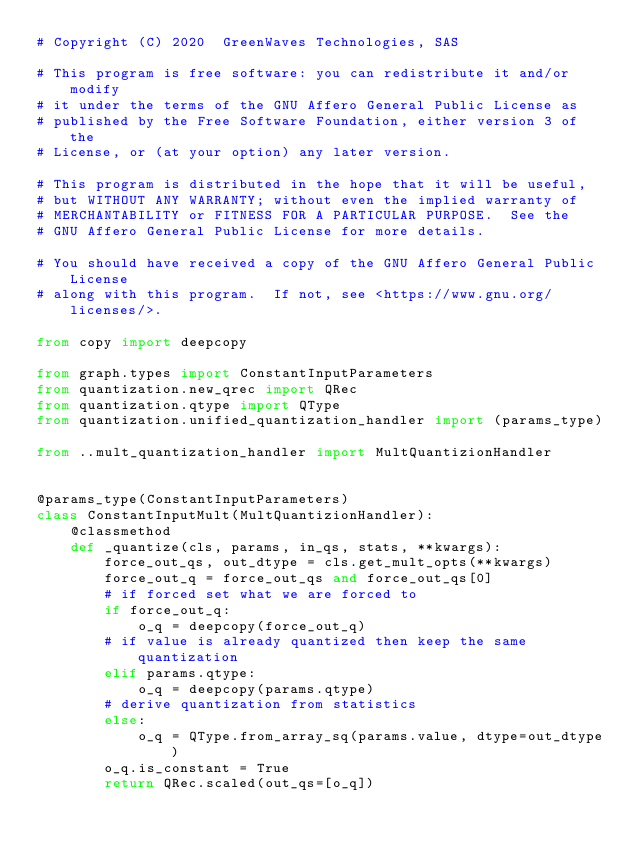Convert code to text. <code><loc_0><loc_0><loc_500><loc_500><_Python_># Copyright (C) 2020  GreenWaves Technologies, SAS

# This program is free software: you can redistribute it and/or modify
# it under the terms of the GNU Affero General Public License as
# published by the Free Software Foundation, either version 3 of the
# License, or (at your option) any later version.

# This program is distributed in the hope that it will be useful,
# but WITHOUT ANY WARRANTY; without even the implied warranty of
# MERCHANTABILITY or FITNESS FOR A PARTICULAR PURPOSE.  See the
# GNU Affero General Public License for more details.

# You should have received a copy of the GNU Affero General Public License
# along with this program.  If not, see <https://www.gnu.org/licenses/>.

from copy import deepcopy

from graph.types import ConstantInputParameters
from quantization.new_qrec import QRec
from quantization.qtype import QType
from quantization.unified_quantization_handler import (params_type)

from ..mult_quantization_handler import MultQuantizionHandler


@params_type(ConstantInputParameters)
class ConstantInputMult(MultQuantizionHandler):
    @classmethod
    def _quantize(cls, params, in_qs, stats, **kwargs):
        force_out_qs, out_dtype = cls.get_mult_opts(**kwargs)
        force_out_q = force_out_qs and force_out_qs[0]
        # if forced set what we are forced to
        if force_out_q:
            o_q = deepcopy(force_out_q)
        # if value is already quantized then keep the same quantization
        elif params.qtype:
            o_q = deepcopy(params.qtype)
        # derive quantization from statistics
        else:
            o_q = QType.from_array_sq(params.value, dtype=out_dtype)
        o_q.is_constant = True
        return QRec.scaled(out_qs=[o_q])
</code> 